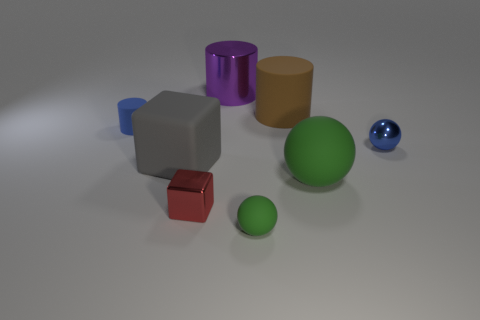Add 1 large red cylinders. How many objects exist? 9 Subtract all cubes. How many objects are left? 6 Subtract 0 brown blocks. How many objects are left? 8 Subtract all small cubes. Subtract all small blue cubes. How many objects are left? 7 Add 1 gray rubber cubes. How many gray rubber cubes are left? 2 Add 4 big green metal cylinders. How many big green metal cylinders exist? 4 